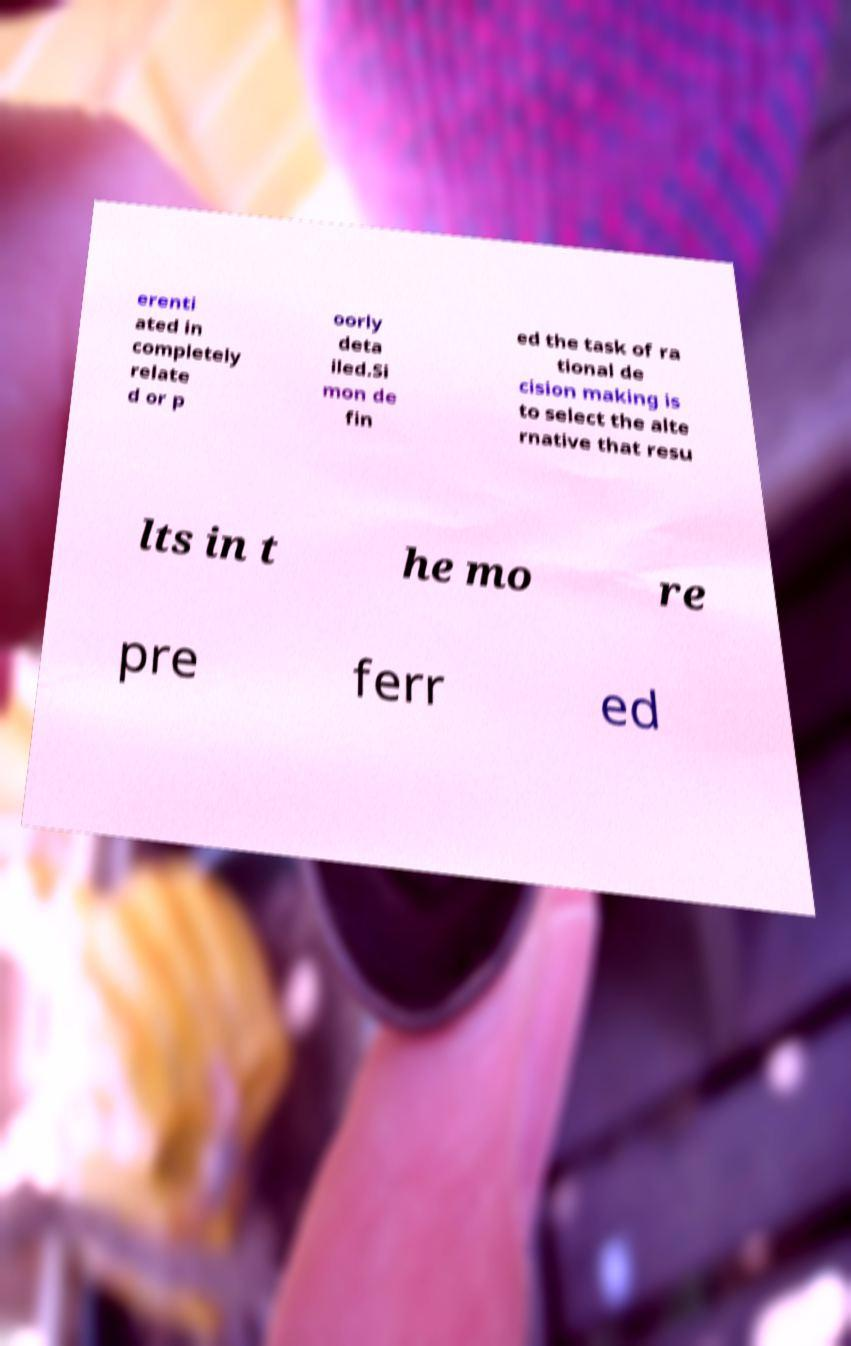Please read and relay the text visible in this image. What does it say? erenti ated in completely relate d or p oorly deta iled.Si mon de fin ed the task of ra tional de cision making is to select the alte rnative that resu lts in t he mo re pre ferr ed 